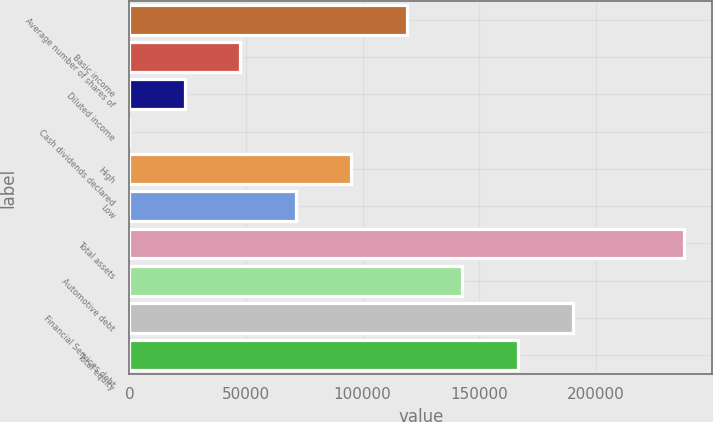Convert chart to OTSL. <chart><loc_0><loc_0><loc_500><loc_500><bar_chart><fcel>Average number of shares of<fcel>Basic income<fcel>Diluted income<fcel>Cash dividends declared<fcel>High<fcel>Low<fcel>Total assets<fcel>Automotive debt<fcel>Financial Services debt<fcel>Total equity<nl><fcel>118976<fcel>47590.9<fcel>23795.9<fcel>0.85<fcel>95180.9<fcel>71385.9<fcel>237951<fcel>142771<fcel>190361<fcel>166566<nl></chart> 